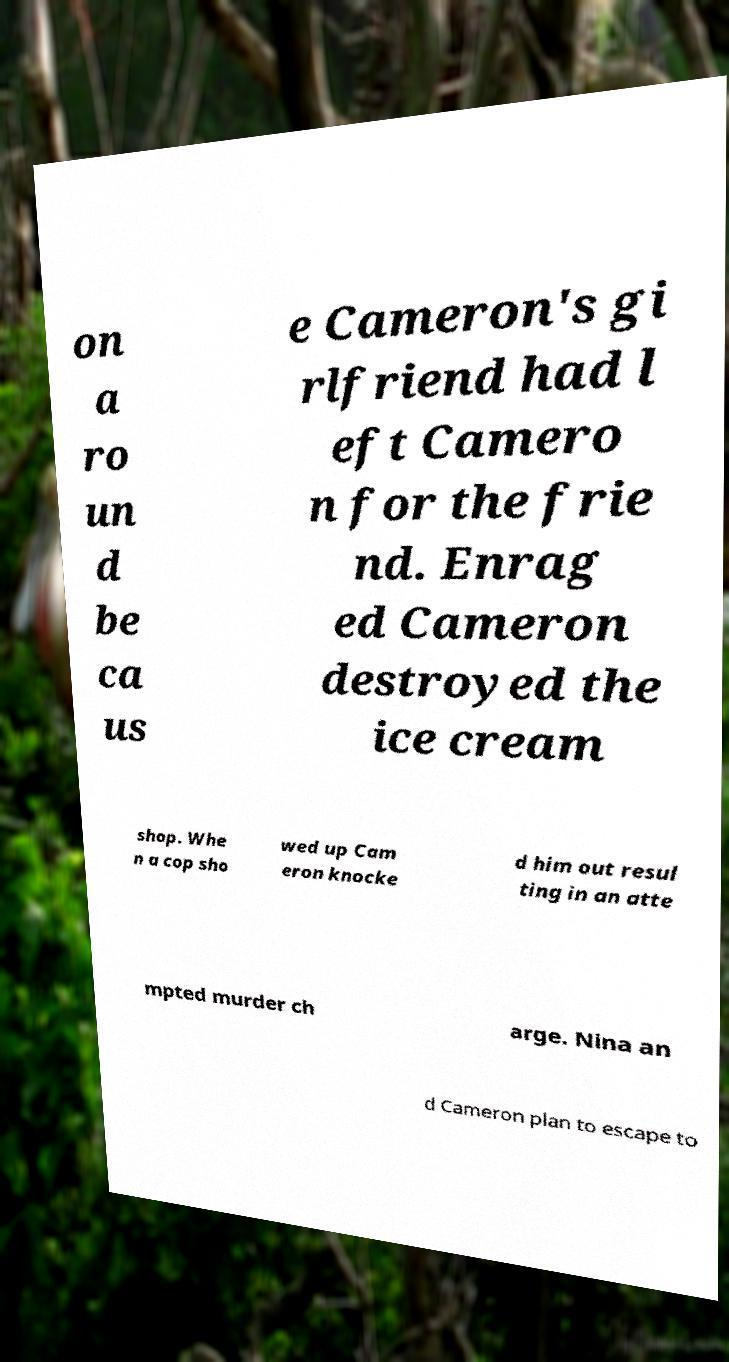For documentation purposes, I need the text within this image transcribed. Could you provide that? on a ro un d be ca us e Cameron's gi rlfriend had l eft Camero n for the frie nd. Enrag ed Cameron destroyed the ice cream shop. Whe n a cop sho wed up Cam eron knocke d him out resul ting in an atte mpted murder ch arge. Nina an d Cameron plan to escape to 